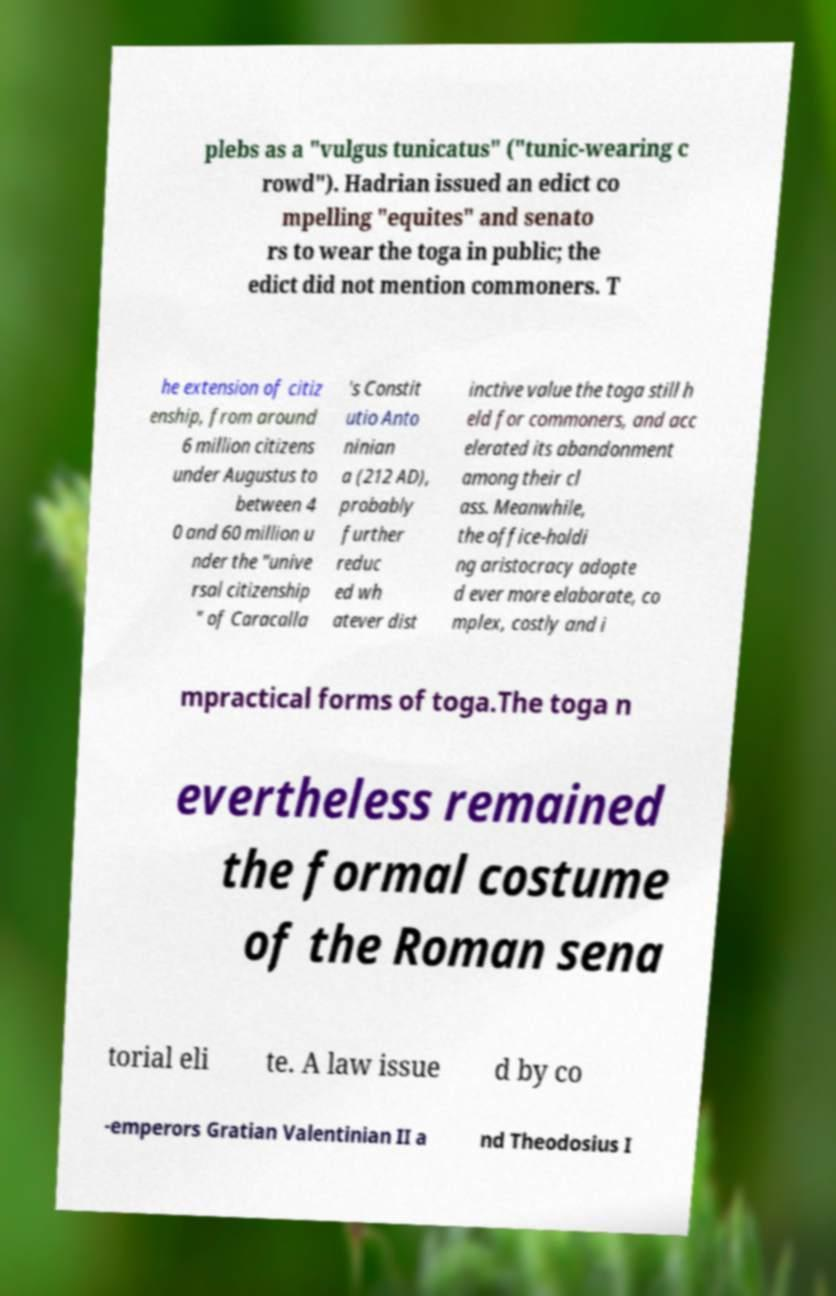Can you accurately transcribe the text from the provided image for me? plebs as a "vulgus tunicatus" ("tunic-wearing c rowd"). Hadrian issued an edict co mpelling "equites" and senato rs to wear the toga in public; the edict did not mention commoners. T he extension of citiz enship, from around 6 million citizens under Augustus to between 4 0 and 60 million u nder the "unive rsal citizenship " of Caracalla 's Constit utio Anto ninian a (212 AD), probably further reduc ed wh atever dist inctive value the toga still h eld for commoners, and acc elerated its abandonment among their cl ass. Meanwhile, the office-holdi ng aristocracy adopte d ever more elaborate, co mplex, costly and i mpractical forms of toga.The toga n evertheless remained the formal costume of the Roman sena torial eli te. A law issue d by co -emperors Gratian Valentinian II a nd Theodosius I 